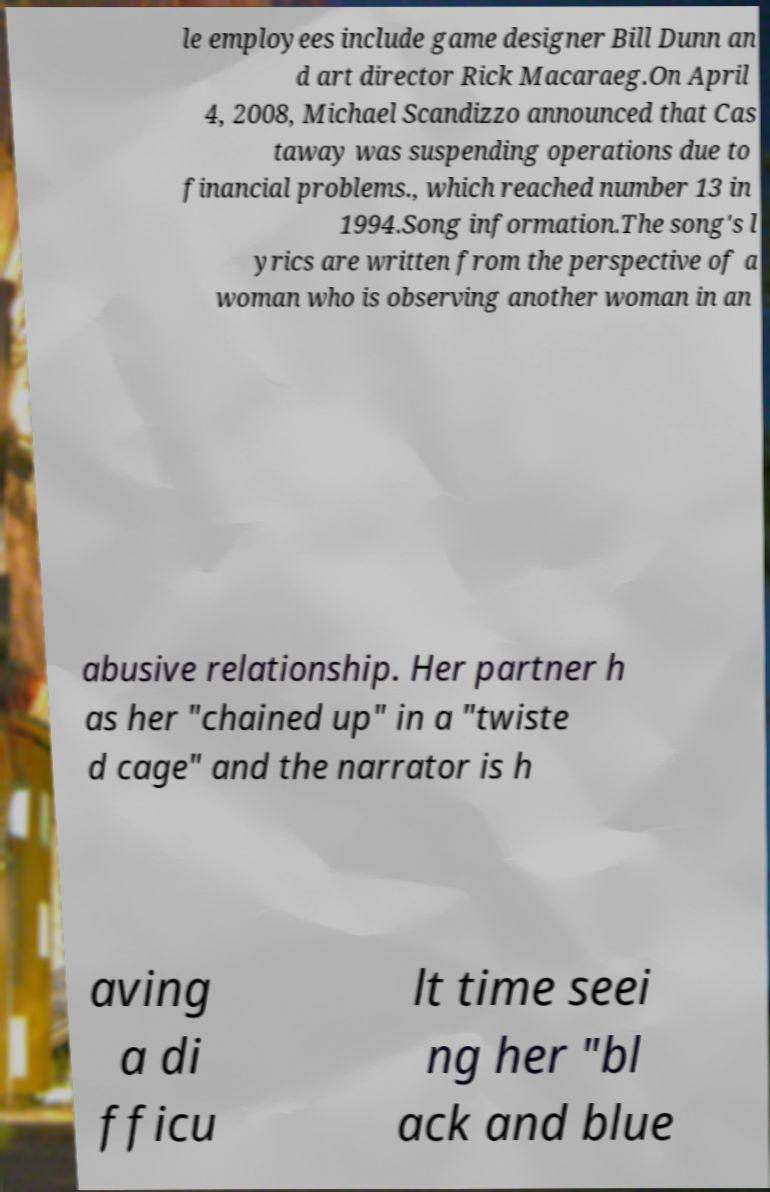There's text embedded in this image that I need extracted. Can you transcribe it verbatim? le employees include game designer Bill Dunn an d art director Rick Macaraeg.On April 4, 2008, Michael Scandizzo announced that Cas taway was suspending operations due to financial problems., which reached number 13 in 1994.Song information.The song's l yrics are written from the perspective of a woman who is observing another woman in an abusive relationship. Her partner h as her "chained up" in a "twiste d cage" and the narrator is h aving a di fficu lt time seei ng her "bl ack and blue 